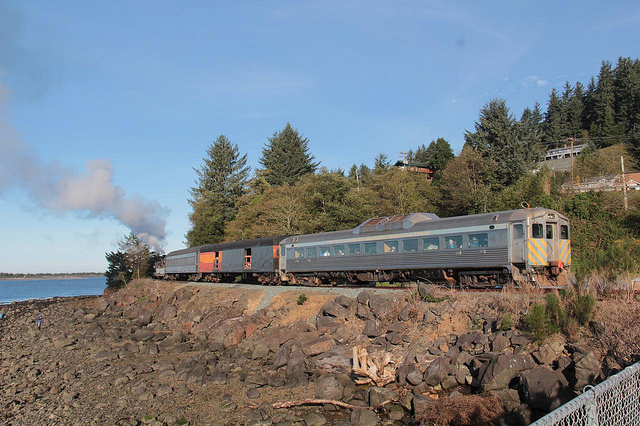<image>What type of train engine is this? I am not sure what type of train engine this is. It could be a passenger, steam or coal engine. What type of train engine is this? I am not sure what type of train engine it is. It can be either passenger, steam or coal engine. 